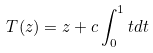<formula> <loc_0><loc_0><loc_500><loc_500>T ( z ) = z + c \int _ { 0 } ^ { 1 } t d t</formula> 